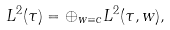Convert formula to latex. <formula><loc_0><loc_0><loc_500><loc_500>L ^ { 2 } ( \tau ) = \oplus _ { w \equiv c } L ^ { 2 } ( \tau , w ) ,</formula> 